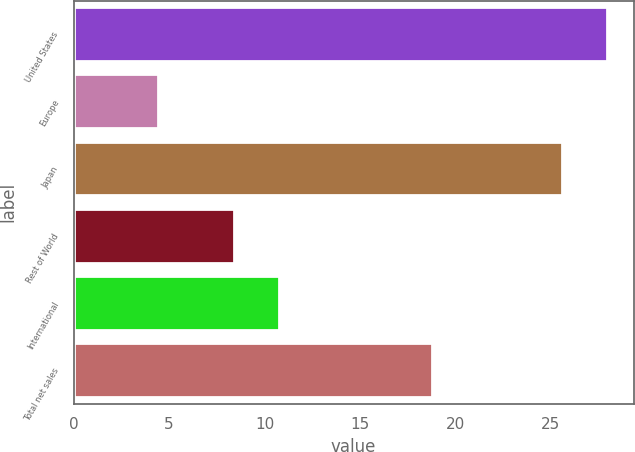<chart> <loc_0><loc_0><loc_500><loc_500><bar_chart><fcel>United States<fcel>Europe<fcel>Japan<fcel>Rest of World<fcel>International<fcel>Total net sales<nl><fcel>27.95<fcel>4.4<fcel>25.6<fcel>8.4<fcel>10.75<fcel>18.8<nl></chart> 